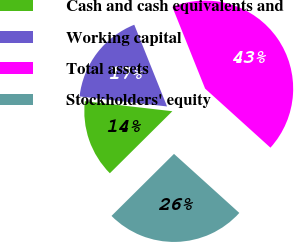<chart> <loc_0><loc_0><loc_500><loc_500><pie_chart><fcel>Cash and cash equivalents and<fcel>Working capital<fcel>Total assets<fcel>Stockholders' equity<nl><fcel>14.26%<fcel>17.11%<fcel>42.77%<fcel>25.86%<nl></chart> 